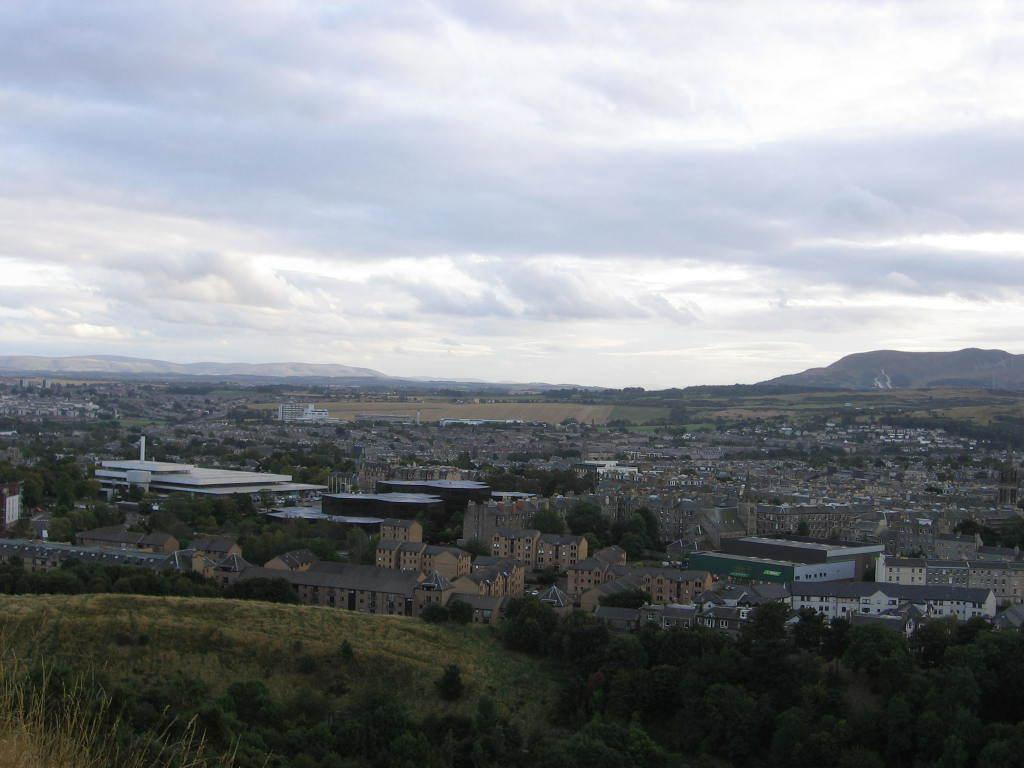What type of structures can be seen in the image? There are buildings in the image. What type of vegetation is present in the image? There are trees, plants, and grass visible in the image. What can be seen in the background of the image? There are mountains and the sky visible in the background of the image. What type of crime is being committed in the image? There is no indication of any crime being committed in the image. How many people are present in the crowd in the image? There is no crowd present in the image. What mode of transport is visible in the image? There is no transport visible in the image. 